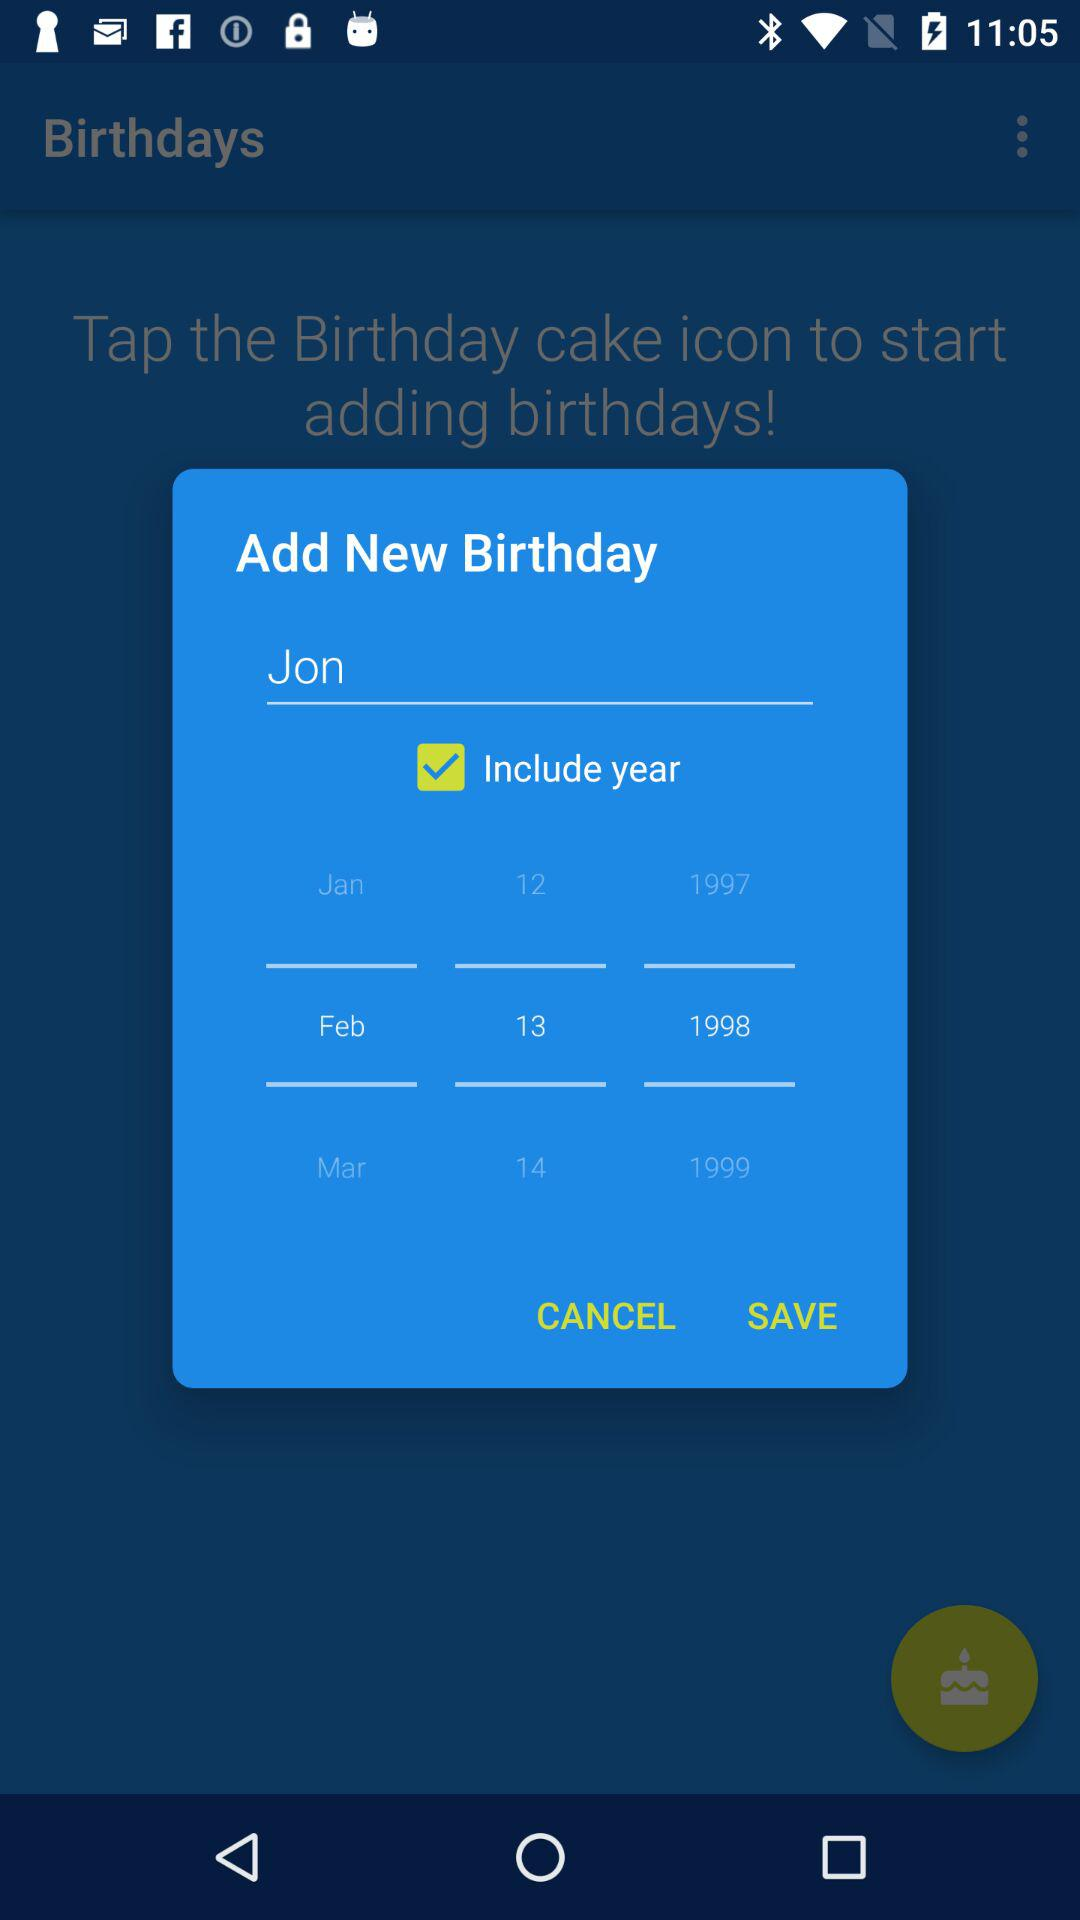Which date of birth is selected? The selected date of birth is February 13, 1998. 